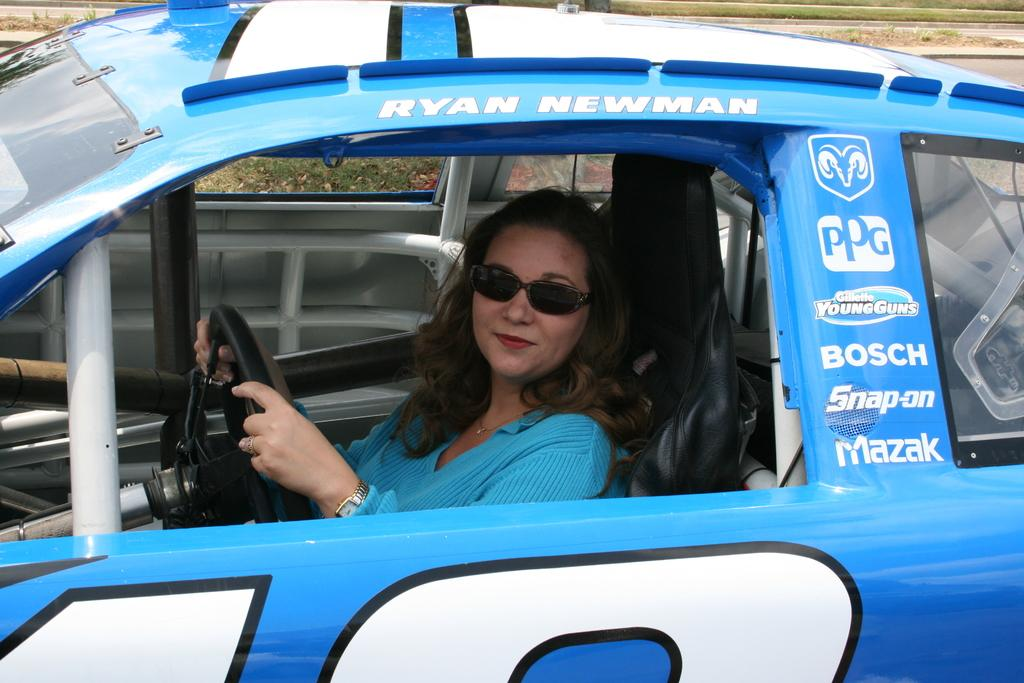Who is present in the image? There is a woman in the image. What is the woman wearing on her head? The woman is wearing a Google device. What other accessory is the woman wearing? The woman is wearing a watch. What is the woman's facial expression? The woman is smiling. What is the woman holding in her hand? The woman is holding a steering wheel. Where is the woman located? The woman is inside a car. What action is the woman performing with the light in the image? There is no light present in the image for the woman to perform any action with. 